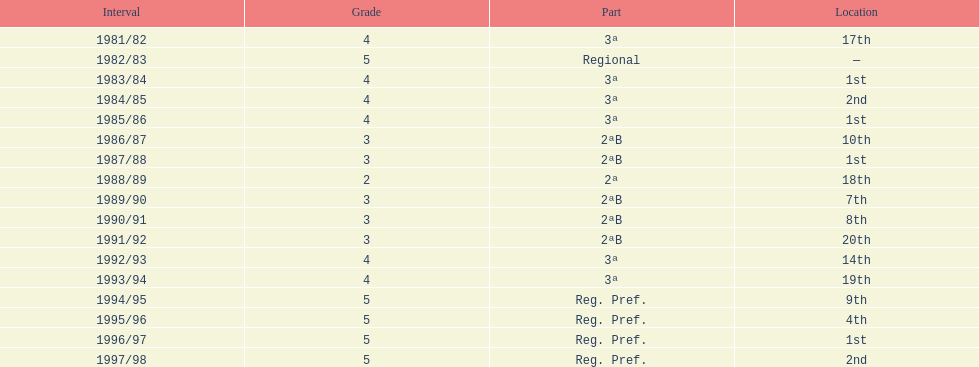How many times total did they finish first 4. 